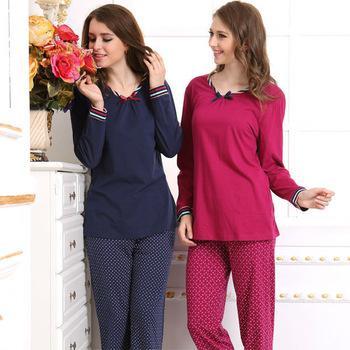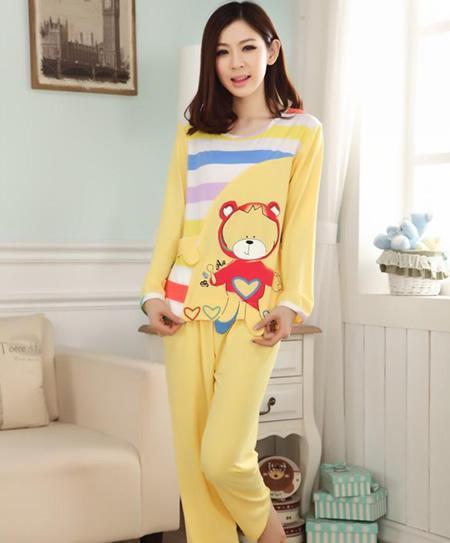The first image is the image on the left, the second image is the image on the right. For the images displayed, is the sentence "One image shows a model in pink loungewear featuring a face on it." factually correct? Answer yes or no. No. The first image is the image on the left, the second image is the image on the right. For the images shown, is this caption "The right image contains a lady wearing pajamas featuring a large teddy bear, not a frog, with a window and a couch in the background." true? Answer yes or no. Yes. 